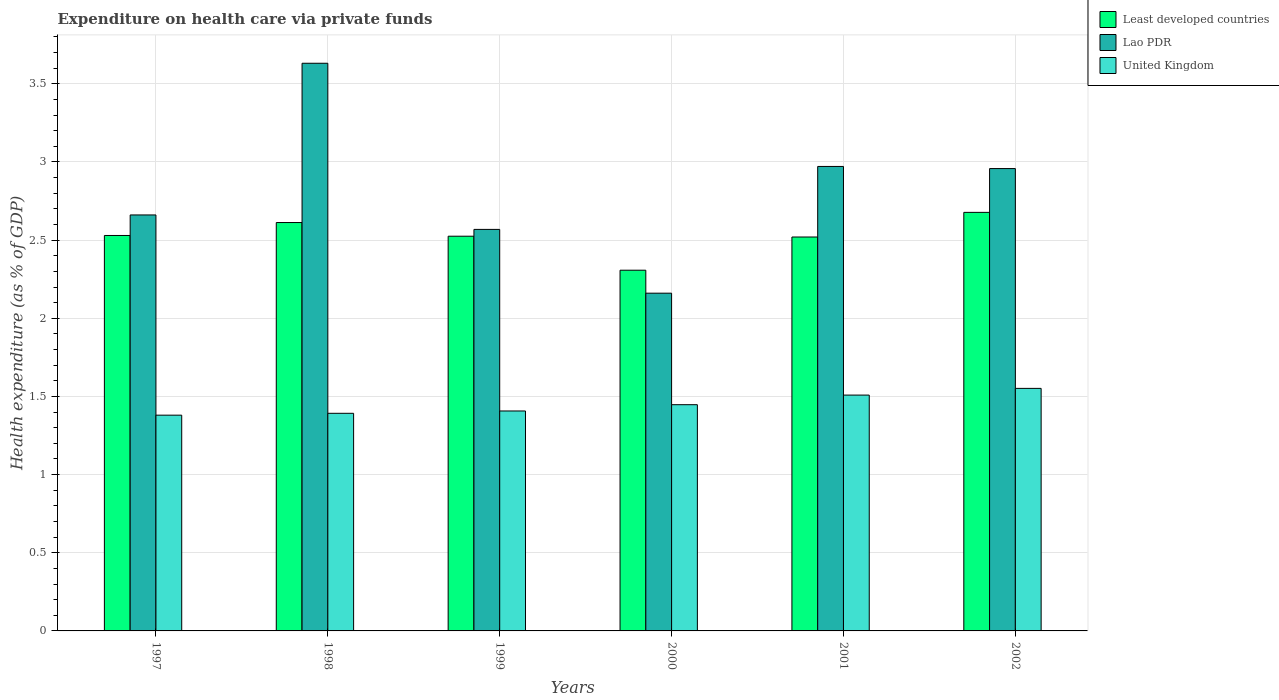What is the label of the 2nd group of bars from the left?
Your response must be concise. 1998. In how many cases, is the number of bars for a given year not equal to the number of legend labels?
Offer a terse response. 0. What is the expenditure made on health care in United Kingdom in 1998?
Your answer should be compact. 1.39. Across all years, what is the maximum expenditure made on health care in Least developed countries?
Provide a short and direct response. 2.68. Across all years, what is the minimum expenditure made on health care in Least developed countries?
Your answer should be very brief. 2.31. In which year was the expenditure made on health care in United Kingdom maximum?
Give a very brief answer. 2002. What is the total expenditure made on health care in United Kingdom in the graph?
Your answer should be very brief. 8.69. What is the difference between the expenditure made on health care in United Kingdom in 1999 and that in 2002?
Give a very brief answer. -0.14. What is the difference between the expenditure made on health care in Lao PDR in 1998 and the expenditure made on health care in Least developed countries in 1999?
Your answer should be compact. 1.11. What is the average expenditure made on health care in United Kingdom per year?
Offer a terse response. 1.45. In the year 2002, what is the difference between the expenditure made on health care in United Kingdom and expenditure made on health care in Least developed countries?
Your answer should be compact. -1.13. In how many years, is the expenditure made on health care in Lao PDR greater than 3 %?
Make the answer very short. 1. What is the ratio of the expenditure made on health care in Least developed countries in 1998 to that in 1999?
Your response must be concise. 1.03. Is the expenditure made on health care in Least developed countries in 2000 less than that in 2001?
Provide a succinct answer. Yes. Is the difference between the expenditure made on health care in United Kingdom in 1998 and 2001 greater than the difference between the expenditure made on health care in Least developed countries in 1998 and 2001?
Your answer should be very brief. No. What is the difference between the highest and the second highest expenditure made on health care in Lao PDR?
Provide a short and direct response. 0.66. What is the difference between the highest and the lowest expenditure made on health care in Lao PDR?
Keep it short and to the point. 1.47. What does the 2nd bar from the left in 1999 represents?
Make the answer very short. Lao PDR. What does the 3rd bar from the right in 1998 represents?
Your answer should be compact. Least developed countries. Are all the bars in the graph horizontal?
Your answer should be compact. No. Are the values on the major ticks of Y-axis written in scientific E-notation?
Ensure brevity in your answer.  No. Does the graph contain any zero values?
Your answer should be compact. No. Does the graph contain grids?
Provide a short and direct response. Yes. How many legend labels are there?
Your answer should be very brief. 3. How are the legend labels stacked?
Provide a short and direct response. Vertical. What is the title of the graph?
Give a very brief answer. Expenditure on health care via private funds. Does "Thailand" appear as one of the legend labels in the graph?
Ensure brevity in your answer.  No. What is the label or title of the X-axis?
Offer a terse response. Years. What is the label or title of the Y-axis?
Your answer should be very brief. Health expenditure (as % of GDP). What is the Health expenditure (as % of GDP) in Least developed countries in 1997?
Your response must be concise. 2.53. What is the Health expenditure (as % of GDP) in Lao PDR in 1997?
Provide a short and direct response. 2.66. What is the Health expenditure (as % of GDP) of United Kingdom in 1997?
Make the answer very short. 1.38. What is the Health expenditure (as % of GDP) in Least developed countries in 1998?
Give a very brief answer. 2.61. What is the Health expenditure (as % of GDP) in Lao PDR in 1998?
Ensure brevity in your answer.  3.63. What is the Health expenditure (as % of GDP) of United Kingdom in 1998?
Ensure brevity in your answer.  1.39. What is the Health expenditure (as % of GDP) in Least developed countries in 1999?
Offer a very short reply. 2.53. What is the Health expenditure (as % of GDP) of Lao PDR in 1999?
Provide a short and direct response. 2.57. What is the Health expenditure (as % of GDP) of United Kingdom in 1999?
Offer a terse response. 1.41. What is the Health expenditure (as % of GDP) in Least developed countries in 2000?
Offer a terse response. 2.31. What is the Health expenditure (as % of GDP) of Lao PDR in 2000?
Offer a terse response. 2.16. What is the Health expenditure (as % of GDP) in United Kingdom in 2000?
Provide a short and direct response. 1.45. What is the Health expenditure (as % of GDP) of Least developed countries in 2001?
Provide a succinct answer. 2.52. What is the Health expenditure (as % of GDP) of Lao PDR in 2001?
Ensure brevity in your answer.  2.97. What is the Health expenditure (as % of GDP) in United Kingdom in 2001?
Offer a terse response. 1.51. What is the Health expenditure (as % of GDP) in Least developed countries in 2002?
Give a very brief answer. 2.68. What is the Health expenditure (as % of GDP) in Lao PDR in 2002?
Give a very brief answer. 2.96. What is the Health expenditure (as % of GDP) in United Kingdom in 2002?
Give a very brief answer. 1.55. Across all years, what is the maximum Health expenditure (as % of GDP) of Least developed countries?
Offer a terse response. 2.68. Across all years, what is the maximum Health expenditure (as % of GDP) of Lao PDR?
Keep it short and to the point. 3.63. Across all years, what is the maximum Health expenditure (as % of GDP) in United Kingdom?
Ensure brevity in your answer.  1.55. Across all years, what is the minimum Health expenditure (as % of GDP) of Least developed countries?
Offer a terse response. 2.31. Across all years, what is the minimum Health expenditure (as % of GDP) in Lao PDR?
Provide a short and direct response. 2.16. Across all years, what is the minimum Health expenditure (as % of GDP) of United Kingdom?
Offer a terse response. 1.38. What is the total Health expenditure (as % of GDP) in Least developed countries in the graph?
Your response must be concise. 15.17. What is the total Health expenditure (as % of GDP) in Lao PDR in the graph?
Your answer should be compact. 16.95. What is the total Health expenditure (as % of GDP) in United Kingdom in the graph?
Provide a succinct answer. 8.69. What is the difference between the Health expenditure (as % of GDP) in Least developed countries in 1997 and that in 1998?
Make the answer very short. -0.08. What is the difference between the Health expenditure (as % of GDP) of Lao PDR in 1997 and that in 1998?
Offer a terse response. -0.97. What is the difference between the Health expenditure (as % of GDP) of United Kingdom in 1997 and that in 1998?
Provide a short and direct response. -0.01. What is the difference between the Health expenditure (as % of GDP) of Least developed countries in 1997 and that in 1999?
Keep it short and to the point. 0. What is the difference between the Health expenditure (as % of GDP) of Lao PDR in 1997 and that in 1999?
Give a very brief answer. 0.09. What is the difference between the Health expenditure (as % of GDP) of United Kingdom in 1997 and that in 1999?
Your response must be concise. -0.03. What is the difference between the Health expenditure (as % of GDP) of Least developed countries in 1997 and that in 2000?
Make the answer very short. 0.22. What is the difference between the Health expenditure (as % of GDP) in Lao PDR in 1997 and that in 2000?
Keep it short and to the point. 0.5. What is the difference between the Health expenditure (as % of GDP) in United Kingdom in 1997 and that in 2000?
Make the answer very short. -0.07. What is the difference between the Health expenditure (as % of GDP) in Least developed countries in 1997 and that in 2001?
Your answer should be very brief. 0.01. What is the difference between the Health expenditure (as % of GDP) in Lao PDR in 1997 and that in 2001?
Your answer should be compact. -0.31. What is the difference between the Health expenditure (as % of GDP) in United Kingdom in 1997 and that in 2001?
Keep it short and to the point. -0.13. What is the difference between the Health expenditure (as % of GDP) of Least developed countries in 1997 and that in 2002?
Provide a short and direct response. -0.15. What is the difference between the Health expenditure (as % of GDP) in Lao PDR in 1997 and that in 2002?
Provide a succinct answer. -0.3. What is the difference between the Health expenditure (as % of GDP) of United Kingdom in 1997 and that in 2002?
Offer a very short reply. -0.17. What is the difference between the Health expenditure (as % of GDP) of Least developed countries in 1998 and that in 1999?
Keep it short and to the point. 0.09. What is the difference between the Health expenditure (as % of GDP) of Lao PDR in 1998 and that in 1999?
Ensure brevity in your answer.  1.06. What is the difference between the Health expenditure (as % of GDP) in United Kingdom in 1998 and that in 1999?
Offer a very short reply. -0.01. What is the difference between the Health expenditure (as % of GDP) in Least developed countries in 1998 and that in 2000?
Offer a terse response. 0.3. What is the difference between the Health expenditure (as % of GDP) in Lao PDR in 1998 and that in 2000?
Give a very brief answer. 1.47. What is the difference between the Health expenditure (as % of GDP) of United Kingdom in 1998 and that in 2000?
Give a very brief answer. -0.06. What is the difference between the Health expenditure (as % of GDP) in Least developed countries in 1998 and that in 2001?
Offer a very short reply. 0.09. What is the difference between the Health expenditure (as % of GDP) of Lao PDR in 1998 and that in 2001?
Offer a terse response. 0.66. What is the difference between the Health expenditure (as % of GDP) in United Kingdom in 1998 and that in 2001?
Offer a very short reply. -0.12. What is the difference between the Health expenditure (as % of GDP) in Least developed countries in 1998 and that in 2002?
Provide a succinct answer. -0.07. What is the difference between the Health expenditure (as % of GDP) of Lao PDR in 1998 and that in 2002?
Ensure brevity in your answer.  0.67. What is the difference between the Health expenditure (as % of GDP) in United Kingdom in 1998 and that in 2002?
Make the answer very short. -0.16. What is the difference between the Health expenditure (as % of GDP) in Least developed countries in 1999 and that in 2000?
Ensure brevity in your answer.  0.22. What is the difference between the Health expenditure (as % of GDP) of Lao PDR in 1999 and that in 2000?
Offer a very short reply. 0.41. What is the difference between the Health expenditure (as % of GDP) in United Kingdom in 1999 and that in 2000?
Offer a terse response. -0.04. What is the difference between the Health expenditure (as % of GDP) in Least developed countries in 1999 and that in 2001?
Your response must be concise. 0.01. What is the difference between the Health expenditure (as % of GDP) in Lao PDR in 1999 and that in 2001?
Ensure brevity in your answer.  -0.4. What is the difference between the Health expenditure (as % of GDP) of United Kingdom in 1999 and that in 2001?
Offer a very short reply. -0.1. What is the difference between the Health expenditure (as % of GDP) in Least developed countries in 1999 and that in 2002?
Your response must be concise. -0.15. What is the difference between the Health expenditure (as % of GDP) in Lao PDR in 1999 and that in 2002?
Offer a terse response. -0.39. What is the difference between the Health expenditure (as % of GDP) of United Kingdom in 1999 and that in 2002?
Provide a succinct answer. -0.14. What is the difference between the Health expenditure (as % of GDP) in Least developed countries in 2000 and that in 2001?
Provide a short and direct response. -0.21. What is the difference between the Health expenditure (as % of GDP) of Lao PDR in 2000 and that in 2001?
Provide a short and direct response. -0.81. What is the difference between the Health expenditure (as % of GDP) of United Kingdom in 2000 and that in 2001?
Give a very brief answer. -0.06. What is the difference between the Health expenditure (as % of GDP) of Least developed countries in 2000 and that in 2002?
Make the answer very short. -0.37. What is the difference between the Health expenditure (as % of GDP) in Lao PDR in 2000 and that in 2002?
Give a very brief answer. -0.8. What is the difference between the Health expenditure (as % of GDP) of United Kingdom in 2000 and that in 2002?
Give a very brief answer. -0.1. What is the difference between the Health expenditure (as % of GDP) of Least developed countries in 2001 and that in 2002?
Offer a terse response. -0.16. What is the difference between the Health expenditure (as % of GDP) in Lao PDR in 2001 and that in 2002?
Your answer should be very brief. 0.01. What is the difference between the Health expenditure (as % of GDP) in United Kingdom in 2001 and that in 2002?
Your response must be concise. -0.04. What is the difference between the Health expenditure (as % of GDP) of Least developed countries in 1997 and the Health expenditure (as % of GDP) of Lao PDR in 1998?
Provide a succinct answer. -1.1. What is the difference between the Health expenditure (as % of GDP) of Least developed countries in 1997 and the Health expenditure (as % of GDP) of United Kingdom in 1998?
Your answer should be compact. 1.14. What is the difference between the Health expenditure (as % of GDP) of Lao PDR in 1997 and the Health expenditure (as % of GDP) of United Kingdom in 1998?
Your answer should be very brief. 1.27. What is the difference between the Health expenditure (as % of GDP) in Least developed countries in 1997 and the Health expenditure (as % of GDP) in Lao PDR in 1999?
Give a very brief answer. -0.04. What is the difference between the Health expenditure (as % of GDP) in Least developed countries in 1997 and the Health expenditure (as % of GDP) in United Kingdom in 1999?
Keep it short and to the point. 1.12. What is the difference between the Health expenditure (as % of GDP) of Lao PDR in 1997 and the Health expenditure (as % of GDP) of United Kingdom in 1999?
Your answer should be very brief. 1.25. What is the difference between the Health expenditure (as % of GDP) of Least developed countries in 1997 and the Health expenditure (as % of GDP) of Lao PDR in 2000?
Your response must be concise. 0.37. What is the difference between the Health expenditure (as % of GDP) in Least developed countries in 1997 and the Health expenditure (as % of GDP) in United Kingdom in 2000?
Your response must be concise. 1.08. What is the difference between the Health expenditure (as % of GDP) of Lao PDR in 1997 and the Health expenditure (as % of GDP) of United Kingdom in 2000?
Your answer should be very brief. 1.21. What is the difference between the Health expenditure (as % of GDP) in Least developed countries in 1997 and the Health expenditure (as % of GDP) in Lao PDR in 2001?
Make the answer very short. -0.44. What is the difference between the Health expenditure (as % of GDP) of Least developed countries in 1997 and the Health expenditure (as % of GDP) of United Kingdom in 2001?
Your response must be concise. 1.02. What is the difference between the Health expenditure (as % of GDP) in Lao PDR in 1997 and the Health expenditure (as % of GDP) in United Kingdom in 2001?
Keep it short and to the point. 1.15. What is the difference between the Health expenditure (as % of GDP) of Least developed countries in 1997 and the Health expenditure (as % of GDP) of Lao PDR in 2002?
Your answer should be very brief. -0.43. What is the difference between the Health expenditure (as % of GDP) of Least developed countries in 1997 and the Health expenditure (as % of GDP) of United Kingdom in 2002?
Your response must be concise. 0.98. What is the difference between the Health expenditure (as % of GDP) of Lao PDR in 1997 and the Health expenditure (as % of GDP) of United Kingdom in 2002?
Keep it short and to the point. 1.11. What is the difference between the Health expenditure (as % of GDP) in Least developed countries in 1998 and the Health expenditure (as % of GDP) in Lao PDR in 1999?
Provide a succinct answer. 0.04. What is the difference between the Health expenditure (as % of GDP) in Least developed countries in 1998 and the Health expenditure (as % of GDP) in United Kingdom in 1999?
Make the answer very short. 1.21. What is the difference between the Health expenditure (as % of GDP) of Lao PDR in 1998 and the Health expenditure (as % of GDP) of United Kingdom in 1999?
Give a very brief answer. 2.22. What is the difference between the Health expenditure (as % of GDP) in Least developed countries in 1998 and the Health expenditure (as % of GDP) in Lao PDR in 2000?
Provide a short and direct response. 0.45. What is the difference between the Health expenditure (as % of GDP) of Least developed countries in 1998 and the Health expenditure (as % of GDP) of United Kingdom in 2000?
Provide a short and direct response. 1.17. What is the difference between the Health expenditure (as % of GDP) in Lao PDR in 1998 and the Health expenditure (as % of GDP) in United Kingdom in 2000?
Offer a terse response. 2.18. What is the difference between the Health expenditure (as % of GDP) of Least developed countries in 1998 and the Health expenditure (as % of GDP) of Lao PDR in 2001?
Make the answer very short. -0.36. What is the difference between the Health expenditure (as % of GDP) of Least developed countries in 1998 and the Health expenditure (as % of GDP) of United Kingdom in 2001?
Keep it short and to the point. 1.1. What is the difference between the Health expenditure (as % of GDP) of Lao PDR in 1998 and the Health expenditure (as % of GDP) of United Kingdom in 2001?
Ensure brevity in your answer.  2.12. What is the difference between the Health expenditure (as % of GDP) in Least developed countries in 1998 and the Health expenditure (as % of GDP) in Lao PDR in 2002?
Offer a very short reply. -0.35. What is the difference between the Health expenditure (as % of GDP) in Least developed countries in 1998 and the Health expenditure (as % of GDP) in United Kingdom in 2002?
Your answer should be compact. 1.06. What is the difference between the Health expenditure (as % of GDP) of Lao PDR in 1998 and the Health expenditure (as % of GDP) of United Kingdom in 2002?
Ensure brevity in your answer.  2.08. What is the difference between the Health expenditure (as % of GDP) in Least developed countries in 1999 and the Health expenditure (as % of GDP) in Lao PDR in 2000?
Give a very brief answer. 0.36. What is the difference between the Health expenditure (as % of GDP) in Least developed countries in 1999 and the Health expenditure (as % of GDP) in United Kingdom in 2000?
Keep it short and to the point. 1.08. What is the difference between the Health expenditure (as % of GDP) of Lao PDR in 1999 and the Health expenditure (as % of GDP) of United Kingdom in 2000?
Ensure brevity in your answer.  1.12. What is the difference between the Health expenditure (as % of GDP) in Least developed countries in 1999 and the Health expenditure (as % of GDP) in Lao PDR in 2001?
Provide a succinct answer. -0.45. What is the difference between the Health expenditure (as % of GDP) in Least developed countries in 1999 and the Health expenditure (as % of GDP) in United Kingdom in 2001?
Provide a succinct answer. 1.02. What is the difference between the Health expenditure (as % of GDP) of Lao PDR in 1999 and the Health expenditure (as % of GDP) of United Kingdom in 2001?
Give a very brief answer. 1.06. What is the difference between the Health expenditure (as % of GDP) of Least developed countries in 1999 and the Health expenditure (as % of GDP) of Lao PDR in 2002?
Ensure brevity in your answer.  -0.43. What is the difference between the Health expenditure (as % of GDP) of Least developed countries in 1999 and the Health expenditure (as % of GDP) of United Kingdom in 2002?
Provide a succinct answer. 0.97. What is the difference between the Health expenditure (as % of GDP) of Lao PDR in 1999 and the Health expenditure (as % of GDP) of United Kingdom in 2002?
Give a very brief answer. 1.02. What is the difference between the Health expenditure (as % of GDP) of Least developed countries in 2000 and the Health expenditure (as % of GDP) of Lao PDR in 2001?
Make the answer very short. -0.66. What is the difference between the Health expenditure (as % of GDP) in Least developed countries in 2000 and the Health expenditure (as % of GDP) in United Kingdom in 2001?
Your answer should be very brief. 0.8. What is the difference between the Health expenditure (as % of GDP) of Lao PDR in 2000 and the Health expenditure (as % of GDP) of United Kingdom in 2001?
Your answer should be very brief. 0.65. What is the difference between the Health expenditure (as % of GDP) in Least developed countries in 2000 and the Health expenditure (as % of GDP) in Lao PDR in 2002?
Ensure brevity in your answer.  -0.65. What is the difference between the Health expenditure (as % of GDP) in Least developed countries in 2000 and the Health expenditure (as % of GDP) in United Kingdom in 2002?
Give a very brief answer. 0.76. What is the difference between the Health expenditure (as % of GDP) of Lao PDR in 2000 and the Health expenditure (as % of GDP) of United Kingdom in 2002?
Provide a short and direct response. 0.61. What is the difference between the Health expenditure (as % of GDP) in Least developed countries in 2001 and the Health expenditure (as % of GDP) in Lao PDR in 2002?
Keep it short and to the point. -0.44. What is the difference between the Health expenditure (as % of GDP) in Least developed countries in 2001 and the Health expenditure (as % of GDP) in United Kingdom in 2002?
Ensure brevity in your answer.  0.97. What is the difference between the Health expenditure (as % of GDP) of Lao PDR in 2001 and the Health expenditure (as % of GDP) of United Kingdom in 2002?
Offer a very short reply. 1.42. What is the average Health expenditure (as % of GDP) of Least developed countries per year?
Make the answer very short. 2.53. What is the average Health expenditure (as % of GDP) in Lao PDR per year?
Offer a very short reply. 2.83. What is the average Health expenditure (as % of GDP) of United Kingdom per year?
Offer a very short reply. 1.45. In the year 1997, what is the difference between the Health expenditure (as % of GDP) of Least developed countries and Health expenditure (as % of GDP) of Lao PDR?
Offer a very short reply. -0.13. In the year 1997, what is the difference between the Health expenditure (as % of GDP) of Least developed countries and Health expenditure (as % of GDP) of United Kingdom?
Your answer should be compact. 1.15. In the year 1997, what is the difference between the Health expenditure (as % of GDP) in Lao PDR and Health expenditure (as % of GDP) in United Kingdom?
Your answer should be compact. 1.28. In the year 1998, what is the difference between the Health expenditure (as % of GDP) in Least developed countries and Health expenditure (as % of GDP) in Lao PDR?
Your answer should be compact. -1.02. In the year 1998, what is the difference between the Health expenditure (as % of GDP) of Least developed countries and Health expenditure (as % of GDP) of United Kingdom?
Provide a short and direct response. 1.22. In the year 1998, what is the difference between the Health expenditure (as % of GDP) of Lao PDR and Health expenditure (as % of GDP) of United Kingdom?
Keep it short and to the point. 2.24. In the year 1999, what is the difference between the Health expenditure (as % of GDP) of Least developed countries and Health expenditure (as % of GDP) of Lao PDR?
Your answer should be compact. -0.04. In the year 1999, what is the difference between the Health expenditure (as % of GDP) in Least developed countries and Health expenditure (as % of GDP) in United Kingdom?
Offer a terse response. 1.12. In the year 1999, what is the difference between the Health expenditure (as % of GDP) of Lao PDR and Health expenditure (as % of GDP) of United Kingdom?
Ensure brevity in your answer.  1.16. In the year 2000, what is the difference between the Health expenditure (as % of GDP) in Least developed countries and Health expenditure (as % of GDP) in Lao PDR?
Your answer should be compact. 0.15. In the year 2000, what is the difference between the Health expenditure (as % of GDP) in Least developed countries and Health expenditure (as % of GDP) in United Kingdom?
Your answer should be compact. 0.86. In the year 2000, what is the difference between the Health expenditure (as % of GDP) in Lao PDR and Health expenditure (as % of GDP) in United Kingdom?
Offer a terse response. 0.71. In the year 2001, what is the difference between the Health expenditure (as % of GDP) of Least developed countries and Health expenditure (as % of GDP) of Lao PDR?
Make the answer very short. -0.45. In the year 2001, what is the difference between the Health expenditure (as % of GDP) in Least developed countries and Health expenditure (as % of GDP) in United Kingdom?
Ensure brevity in your answer.  1.01. In the year 2001, what is the difference between the Health expenditure (as % of GDP) of Lao PDR and Health expenditure (as % of GDP) of United Kingdom?
Provide a succinct answer. 1.46. In the year 2002, what is the difference between the Health expenditure (as % of GDP) in Least developed countries and Health expenditure (as % of GDP) in Lao PDR?
Ensure brevity in your answer.  -0.28. In the year 2002, what is the difference between the Health expenditure (as % of GDP) of Least developed countries and Health expenditure (as % of GDP) of United Kingdom?
Give a very brief answer. 1.13. In the year 2002, what is the difference between the Health expenditure (as % of GDP) of Lao PDR and Health expenditure (as % of GDP) of United Kingdom?
Your answer should be compact. 1.41. What is the ratio of the Health expenditure (as % of GDP) of Least developed countries in 1997 to that in 1998?
Your response must be concise. 0.97. What is the ratio of the Health expenditure (as % of GDP) of Lao PDR in 1997 to that in 1998?
Make the answer very short. 0.73. What is the ratio of the Health expenditure (as % of GDP) of Least developed countries in 1997 to that in 1999?
Provide a succinct answer. 1. What is the ratio of the Health expenditure (as % of GDP) in Lao PDR in 1997 to that in 1999?
Your response must be concise. 1.04. What is the ratio of the Health expenditure (as % of GDP) of Least developed countries in 1997 to that in 2000?
Provide a succinct answer. 1.1. What is the ratio of the Health expenditure (as % of GDP) of Lao PDR in 1997 to that in 2000?
Make the answer very short. 1.23. What is the ratio of the Health expenditure (as % of GDP) of United Kingdom in 1997 to that in 2000?
Ensure brevity in your answer.  0.95. What is the ratio of the Health expenditure (as % of GDP) in Lao PDR in 1997 to that in 2001?
Provide a succinct answer. 0.9. What is the ratio of the Health expenditure (as % of GDP) of United Kingdom in 1997 to that in 2001?
Provide a succinct answer. 0.91. What is the ratio of the Health expenditure (as % of GDP) of Least developed countries in 1997 to that in 2002?
Your answer should be compact. 0.94. What is the ratio of the Health expenditure (as % of GDP) of Lao PDR in 1997 to that in 2002?
Keep it short and to the point. 0.9. What is the ratio of the Health expenditure (as % of GDP) in United Kingdom in 1997 to that in 2002?
Ensure brevity in your answer.  0.89. What is the ratio of the Health expenditure (as % of GDP) in Least developed countries in 1998 to that in 1999?
Offer a very short reply. 1.03. What is the ratio of the Health expenditure (as % of GDP) of Lao PDR in 1998 to that in 1999?
Provide a short and direct response. 1.41. What is the ratio of the Health expenditure (as % of GDP) of United Kingdom in 1998 to that in 1999?
Your answer should be very brief. 0.99. What is the ratio of the Health expenditure (as % of GDP) in Least developed countries in 1998 to that in 2000?
Offer a very short reply. 1.13. What is the ratio of the Health expenditure (as % of GDP) of Lao PDR in 1998 to that in 2000?
Your answer should be very brief. 1.68. What is the ratio of the Health expenditure (as % of GDP) in United Kingdom in 1998 to that in 2000?
Provide a succinct answer. 0.96. What is the ratio of the Health expenditure (as % of GDP) in Least developed countries in 1998 to that in 2001?
Keep it short and to the point. 1.04. What is the ratio of the Health expenditure (as % of GDP) of Lao PDR in 1998 to that in 2001?
Your answer should be compact. 1.22. What is the ratio of the Health expenditure (as % of GDP) of United Kingdom in 1998 to that in 2001?
Offer a terse response. 0.92. What is the ratio of the Health expenditure (as % of GDP) in Least developed countries in 1998 to that in 2002?
Make the answer very short. 0.98. What is the ratio of the Health expenditure (as % of GDP) of Lao PDR in 1998 to that in 2002?
Ensure brevity in your answer.  1.23. What is the ratio of the Health expenditure (as % of GDP) in United Kingdom in 1998 to that in 2002?
Make the answer very short. 0.9. What is the ratio of the Health expenditure (as % of GDP) in Least developed countries in 1999 to that in 2000?
Keep it short and to the point. 1.09. What is the ratio of the Health expenditure (as % of GDP) in Lao PDR in 1999 to that in 2000?
Your answer should be very brief. 1.19. What is the ratio of the Health expenditure (as % of GDP) in United Kingdom in 1999 to that in 2000?
Give a very brief answer. 0.97. What is the ratio of the Health expenditure (as % of GDP) in Lao PDR in 1999 to that in 2001?
Ensure brevity in your answer.  0.86. What is the ratio of the Health expenditure (as % of GDP) of United Kingdom in 1999 to that in 2001?
Your response must be concise. 0.93. What is the ratio of the Health expenditure (as % of GDP) in Least developed countries in 1999 to that in 2002?
Keep it short and to the point. 0.94. What is the ratio of the Health expenditure (as % of GDP) of Lao PDR in 1999 to that in 2002?
Your answer should be very brief. 0.87. What is the ratio of the Health expenditure (as % of GDP) of United Kingdom in 1999 to that in 2002?
Give a very brief answer. 0.91. What is the ratio of the Health expenditure (as % of GDP) of Least developed countries in 2000 to that in 2001?
Give a very brief answer. 0.92. What is the ratio of the Health expenditure (as % of GDP) in Lao PDR in 2000 to that in 2001?
Keep it short and to the point. 0.73. What is the ratio of the Health expenditure (as % of GDP) of United Kingdom in 2000 to that in 2001?
Provide a succinct answer. 0.96. What is the ratio of the Health expenditure (as % of GDP) of Least developed countries in 2000 to that in 2002?
Give a very brief answer. 0.86. What is the ratio of the Health expenditure (as % of GDP) of Lao PDR in 2000 to that in 2002?
Offer a terse response. 0.73. What is the ratio of the Health expenditure (as % of GDP) in United Kingdom in 2000 to that in 2002?
Make the answer very short. 0.93. What is the ratio of the Health expenditure (as % of GDP) of Least developed countries in 2001 to that in 2002?
Provide a succinct answer. 0.94. What is the ratio of the Health expenditure (as % of GDP) in United Kingdom in 2001 to that in 2002?
Offer a very short reply. 0.97. What is the difference between the highest and the second highest Health expenditure (as % of GDP) of Least developed countries?
Keep it short and to the point. 0.07. What is the difference between the highest and the second highest Health expenditure (as % of GDP) in Lao PDR?
Offer a very short reply. 0.66. What is the difference between the highest and the second highest Health expenditure (as % of GDP) of United Kingdom?
Your answer should be very brief. 0.04. What is the difference between the highest and the lowest Health expenditure (as % of GDP) in Least developed countries?
Keep it short and to the point. 0.37. What is the difference between the highest and the lowest Health expenditure (as % of GDP) in Lao PDR?
Your answer should be compact. 1.47. What is the difference between the highest and the lowest Health expenditure (as % of GDP) in United Kingdom?
Make the answer very short. 0.17. 